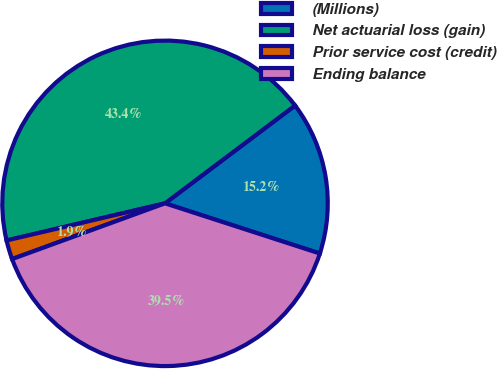<chart> <loc_0><loc_0><loc_500><loc_500><pie_chart><fcel>(Millions)<fcel>Net actuarial loss (gain)<fcel>Prior service cost (credit)<fcel>Ending balance<nl><fcel>15.25%<fcel>43.4%<fcel>1.9%<fcel>39.45%<nl></chart> 